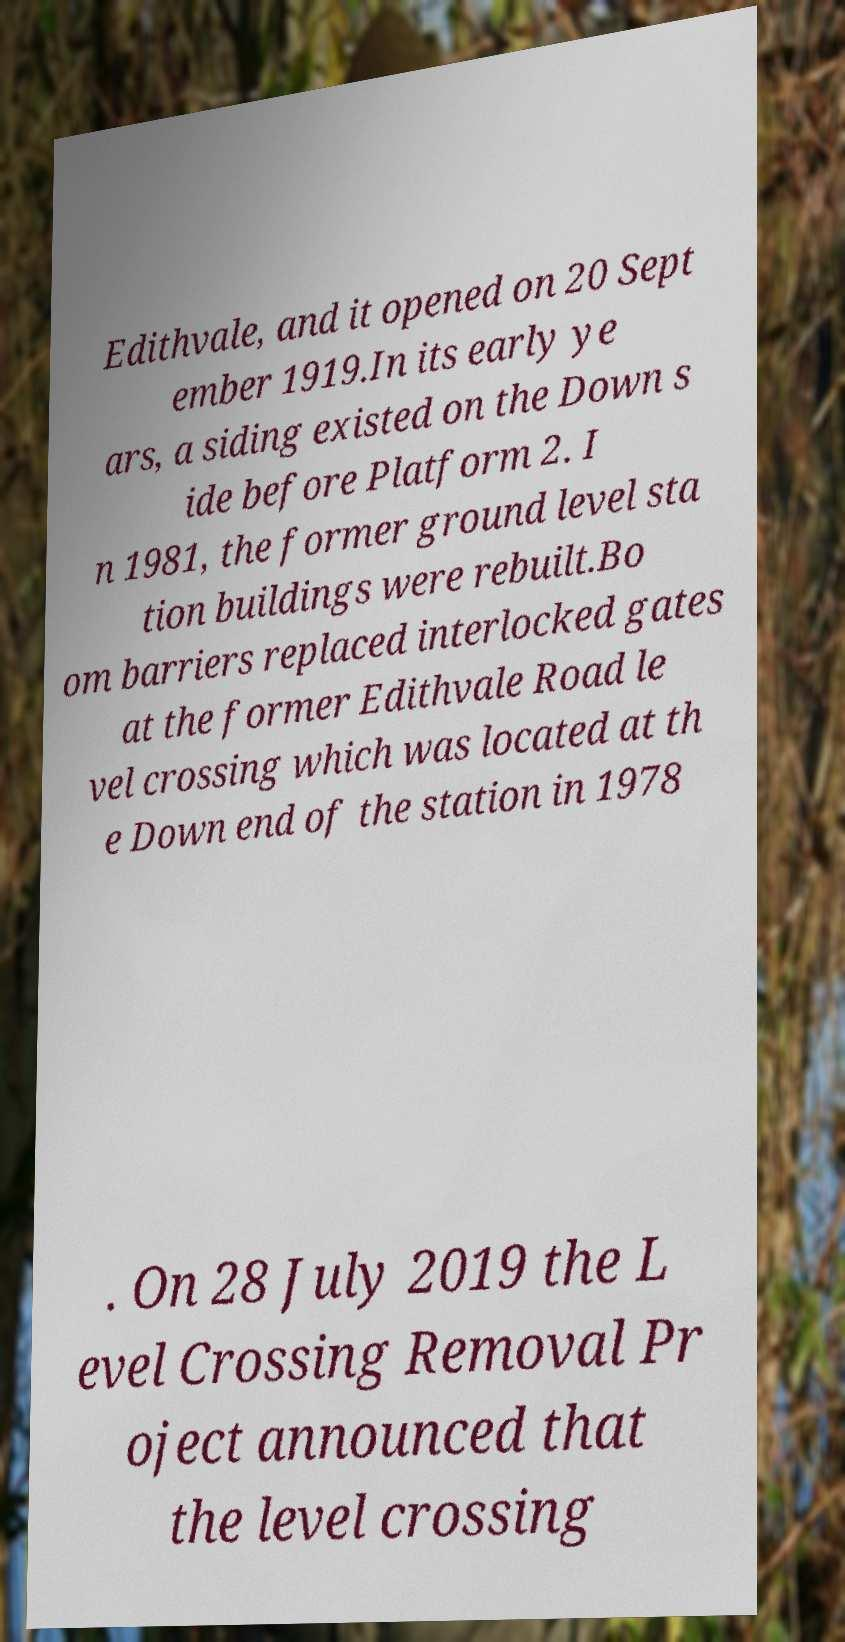Can you accurately transcribe the text from the provided image for me? Edithvale, and it opened on 20 Sept ember 1919.In its early ye ars, a siding existed on the Down s ide before Platform 2. I n 1981, the former ground level sta tion buildings were rebuilt.Bo om barriers replaced interlocked gates at the former Edithvale Road le vel crossing which was located at th e Down end of the station in 1978 . On 28 July 2019 the L evel Crossing Removal Pr oject announced that the level crossing 